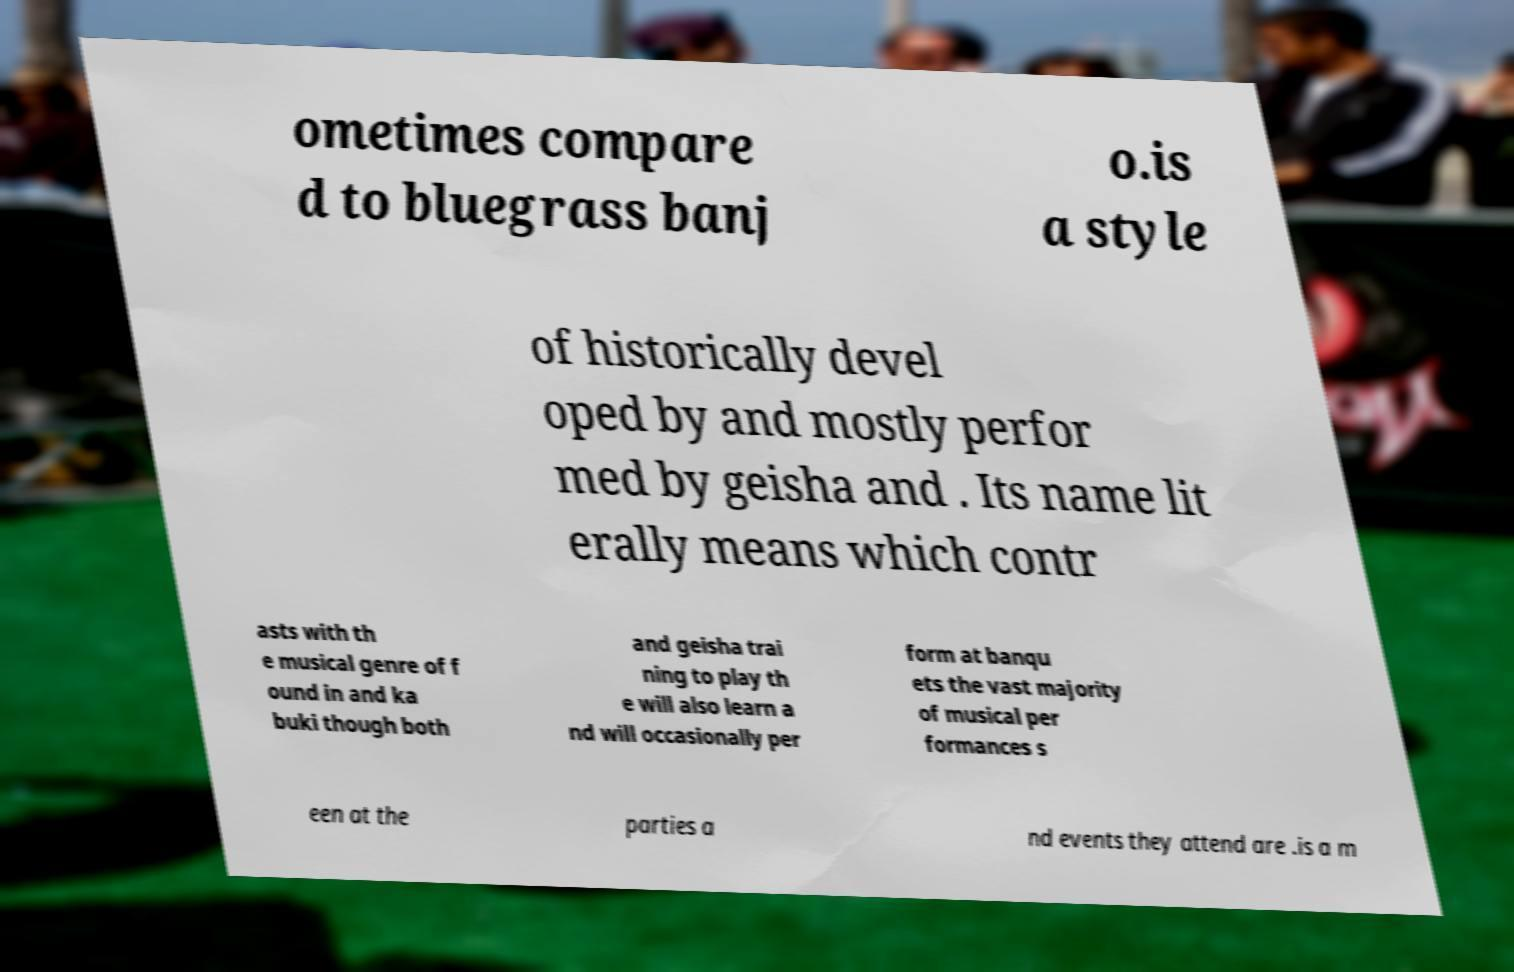Please identify and transcribe the text found in this image. ometimes compare d to bluegrass banj o.is a style of historically devel oped by and mostly perfor med by geisha and . Its name lit erally means which contr asts with th e musical genre of f ound in and ka buki though both and geisha trai ning to play th e will also learn a nd will occasionally per form at banqu ets the vast majority of musical per formances s een at the parties a nd events they attend are .is a m 